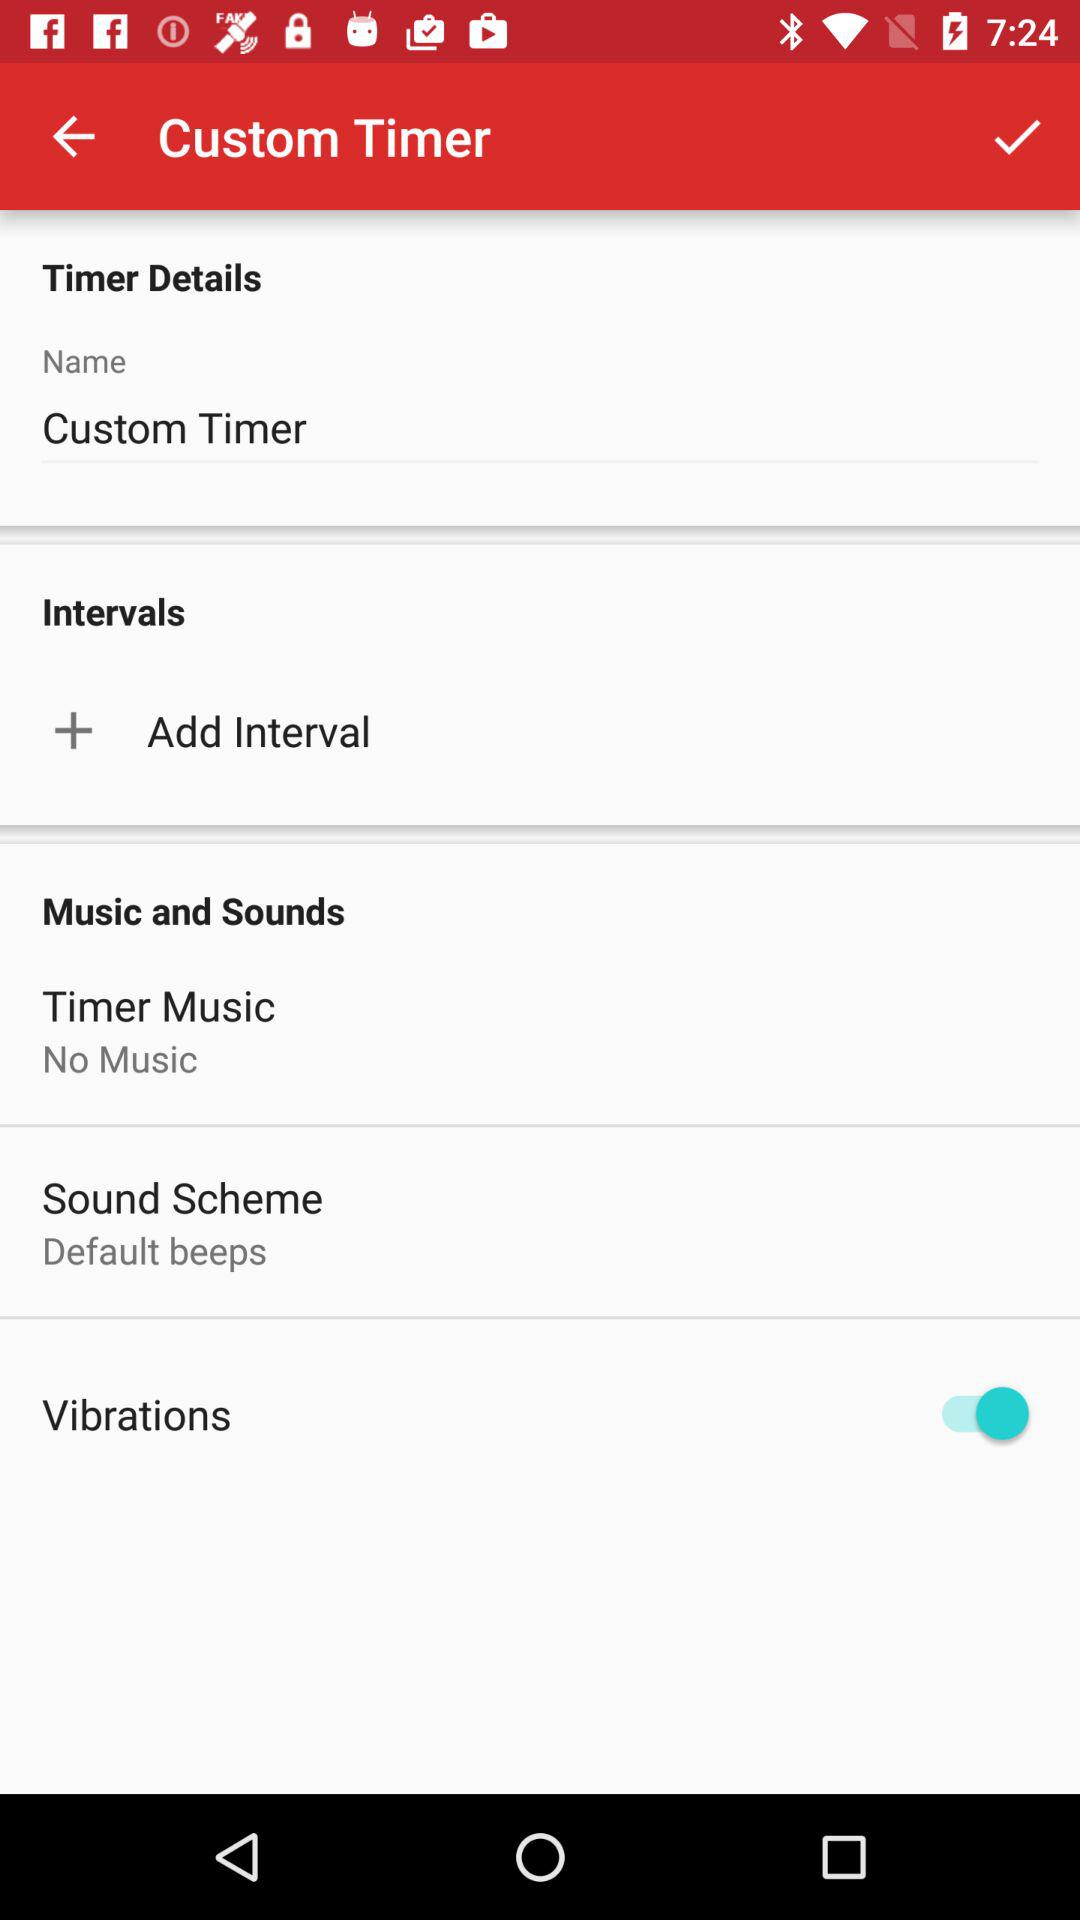What is the status of the vibarations? The status is on. 